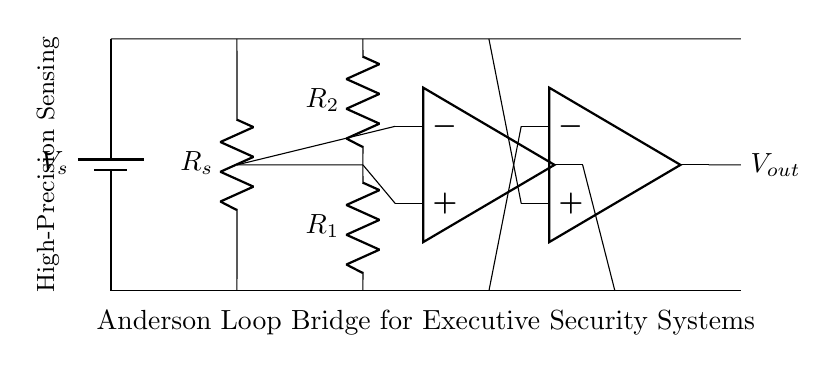What is the purpose of the voltage source in this circuit? The voltage source provides the necessary electrical energy for the circuit's operation and establishes a potential difference across the sensing element.
Answer: Power supply What do the resistors R1 and R2 represent in this bridge? R1 and R2 act as reference resistors, providing a calibrated resistance to balance the bridge, which is essential for accurate sensing and measurement.
Answer: Reference resistors How many operational amplifiers are present in this circuit? There are two operational amplifiers in this circuit, which are used to amplify the output signals from the sensing element and the reference resistors.
Answer: Two What is the output of the Anderson loop bridge circuit? The output, denoted as Vout, represents the voltage difference that results from the balance of the bridge and reacts to the changes in the sensed variable.
Answer: Vout In what application is this Anderson loop bridge circuit primarily used? This Anderson loop bridge circuit is primarily used in executive security systems for high-precision sensing, capable of detecting minute changes in the environment.
Answer: Executive security systems How does the sensing element relate to the overall function of the bridge? The sensing element (Rs) detects variations in the measured parameter, causing the bridge to become unbalanced, which can be determined by the output voltage, Vout.
Answer: Sensing variations What is the configuration type of this circuit? This circuit is a bridge configuration, specifically designed for high precision measurements by comparing the sensing element against reference resistors.
Answer: Bridge configuration 